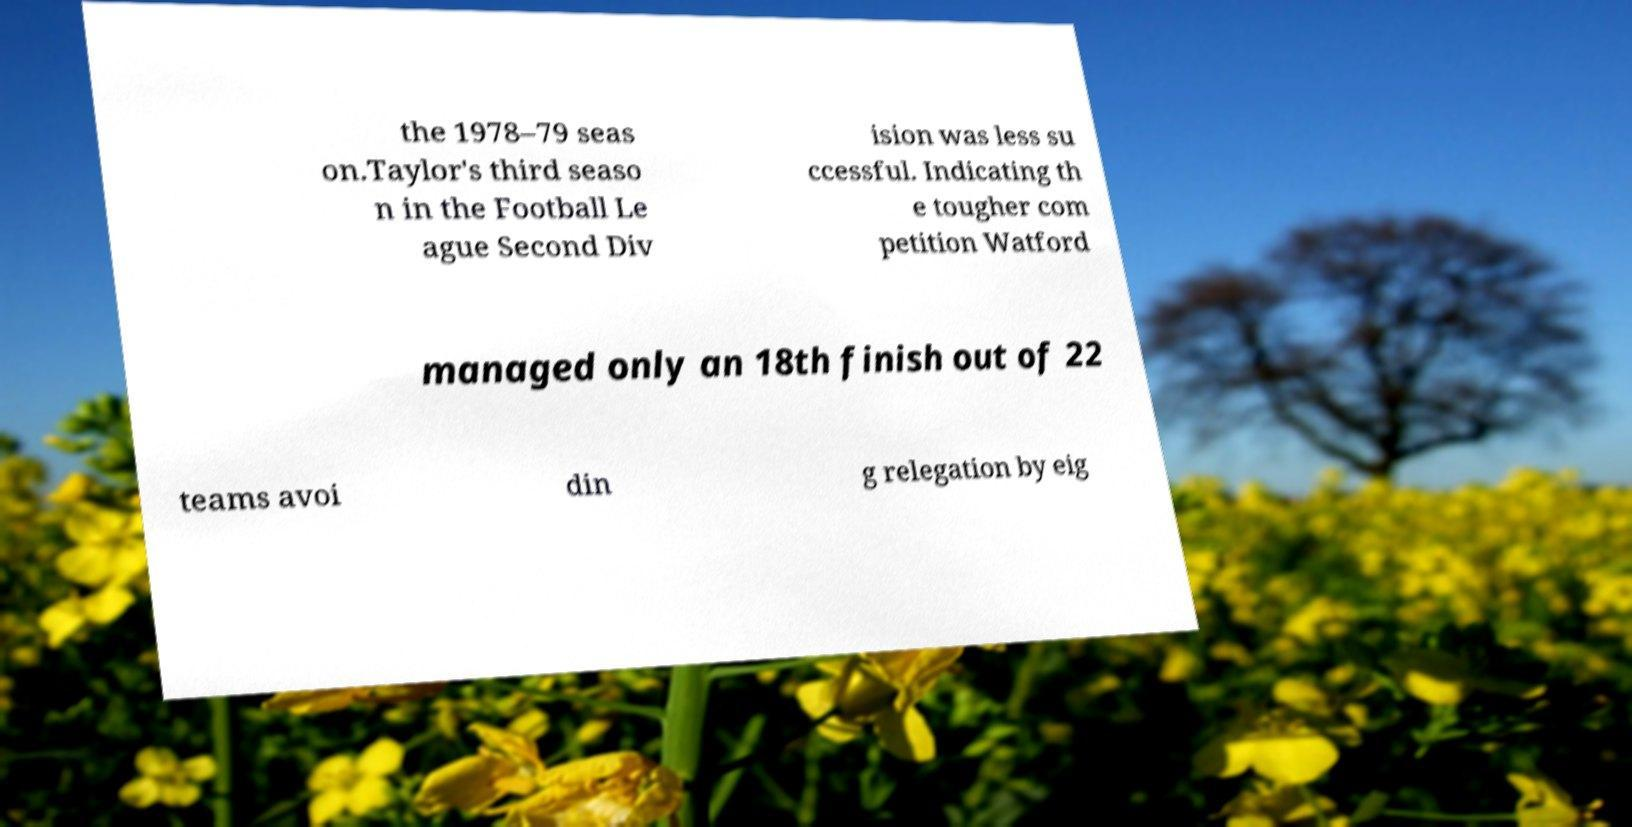Could you assist in decoding the text presented in this image and type it out clearly? the 1978–79 seas on.Taylor's third seaso n in the Football Le ague Second Div ision was less su ccessful. Indicating th e tougher com petition Watford managed only an 18th finish out of 22 teams avoi din g relegation by eig 